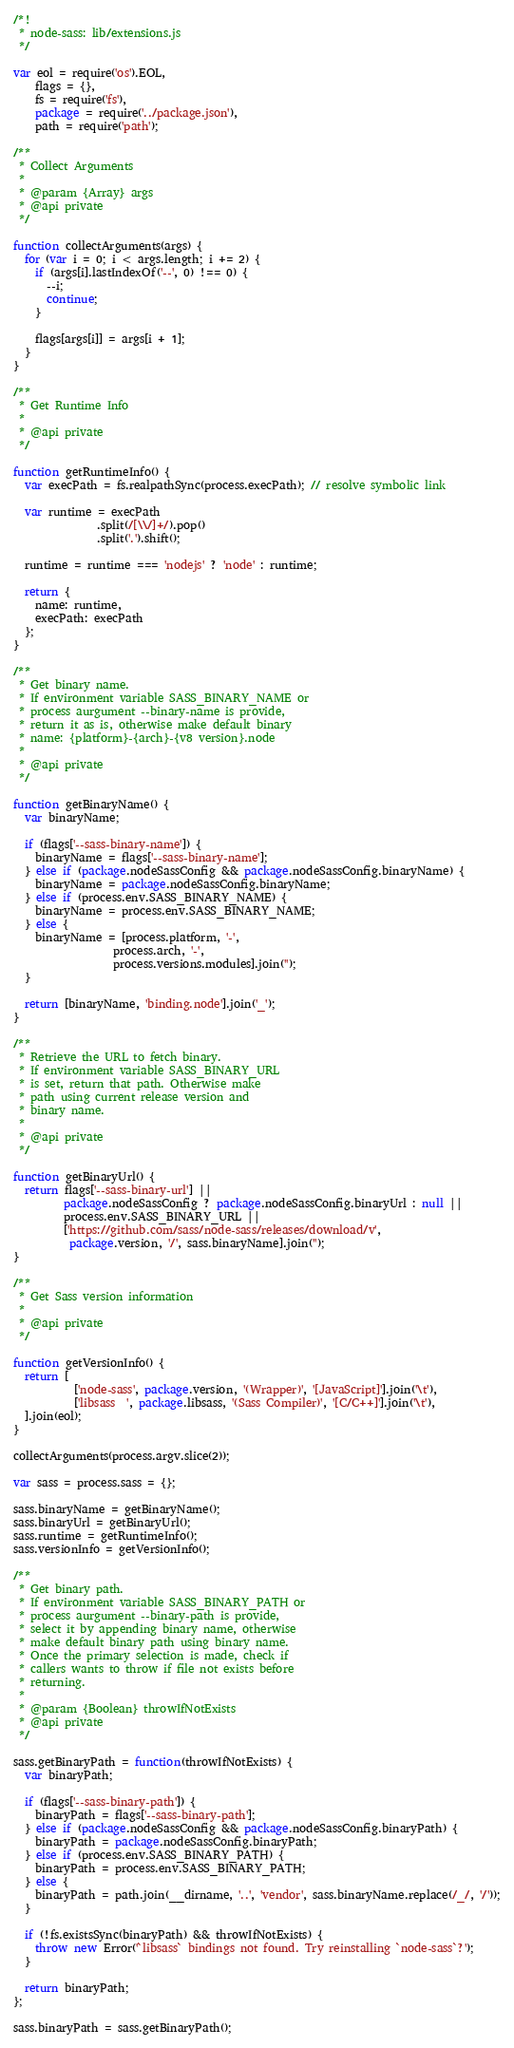<code> <loc_0><loc_0><loc_500><loc_500><_JavaScript_>/*!
 * node-sass: lib/extensions.js
 */

var eol = require('os').EOL,
    flags = {},
    fs = require('fs'),
    package = require('../package.json'),
    path = require('path');

/**
 * Collect Arguments
 *
 * @param {Array} args
 * @api private
 */

function collectArguments(args) {
  for (var i = 0; i < args.length; i += 2) {
    if (args[i].lastIndexOf('--', 0) !== 0) {
      --i;
      continue;
    }

    flags[args[i]] = args[i + 1];
  }
}

/**
 * Get Runtime Info
 *
 * @api private
 */

function getRuntimeInfo() {
  var execPath = fs.realpathSync(process.execPath); // resolve symbolic link

  var runtime = execPath
               .split(/[\\/]+/).pop()
               .split('.').shift();

  runtime = runtime === 'nodejs' ? 'node' : runtime;

  return {
    name: runtime,
    execPath: execPath
  };
}

/**
 * Get binary name.
 * If environment variable SASS_BINARY_NAME or
 * process aurgument --binary-name is provide,
 * return it as is, otherwise make default binary
 * name: {platform}-{arch}-{v8 version}.node
 *
 * @api private
 */

function getBinaryName() {
  var binaryName;

  if (flags['--sass-binary-name']) {
    binaryName = flags['--sass-binary-name'];
  } else if (package.nodeSassConfig && package.nodeSassConfig.binaryName) {
    binaryName = package.nodeSassConfig.binaryName;
  } else if (process.env.SASS_BINARY_NAME) {
    binaryName = process.env.SASS_BINARY_NAME;
  } else {
    binaryName = [process.platform, '-',
                  process.arch, '-',
                  process.versions.modules].join('');
  }

  return [binaryName, 'binding.node'].join('_');
}

/**
 * Retrieve the URL to fetch binary.
 * If environment variable SASS_BINARY_URL
 * is set, return that path. Otherwise make
 * path using current release version and
 * binary name.
 *
 * @api private
 */

function getBinaryUrl() {
  return flags['--sass-binary-url'] ||
         package.nodeSassConfig ? package.nodeSassConfig.binaryUrl : null ||
         process.env.SASS_BINARY_URL ||
         ['https://github.com/sass/node-sass/releases/download/v',
          package.version, '/', sass.binaryName].join('');
}

/**
 * Get Sass version information
 *
 * @api private
 */

function getVersionInfo() {
  return [
           ['node-sass', package.version, '(Wrapper)', '[JavaScript]'].join('\t'),
           ['libsass  ', package.libsass, '(Sass Compiler)', '[C/C++]'].join('\t'),
  ].join(eol);
}

collectArguments(process.argv.slice(2));

var sass = process.sass = {};

sass.binaryName = getBinaryName();
sass.binaryUrl = getBinaryUrl();
sass.runtime = getRuntimeInfo();
sass.versionInfo = getVersionInfo();

/**
 * Get binary path.
 * If environment variable SASS_BINARY_PATH or
 * process aurgument --binary-path is provide,
 * select it by appending binary name, otherwise
 * make default binary path using binary name.
 * Once the primary selection is made, check if
 * callers wants to throw if file not exists before
 * returning.
 *
 * @param {Boolean} throwIfNotExists
 * @api private
 */

sass.getBinaryPath = function(throwIfNotExists) {
  var binaryPath;

  if (flags['--sass-binary-path']) {
    binaryPath = flags['--sass-binary-path'];
  } else if (package.nodeSassConfig && package.nodeSassConfig.binaryPath) {
    binaryPath = package.nodeSassConfig.binaryPath;
  } else if (process.env.SASS_BINARY_PATH) {
    binaryPath = process.env.SASS_BINARY_PATH;
  } else {
    binaryPath = path.join(__dirname, '..', 'vendor', sass.binaryName.replace(/_/, '/'));
  }

  if (!fs.existsSync(binaryPath) && throwIfNotExists) {
    throw new Error('`libsass` bindings not found. Try reinstalling `node-sass`?');
  }

  return binaryPath;
};

sass.binaryPath = sass.getBinaryPath();
</code> 